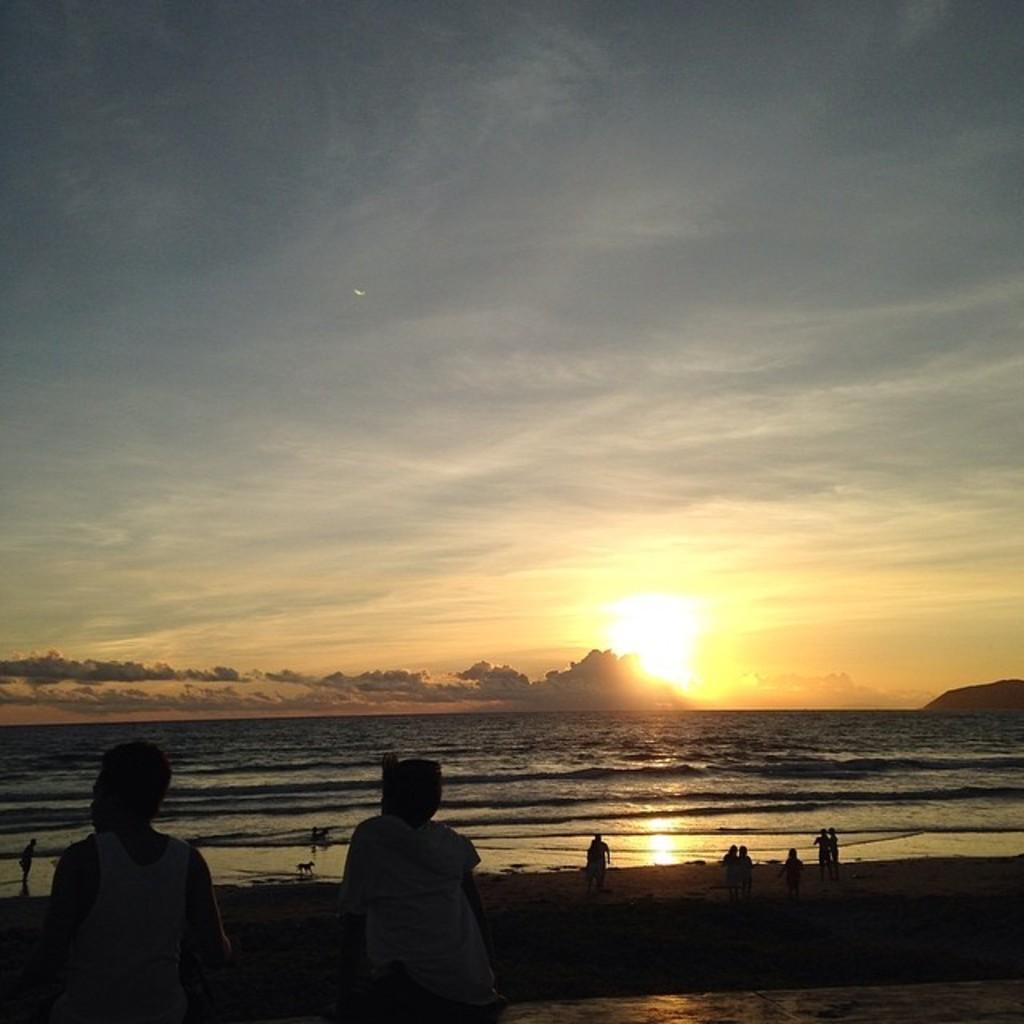In one or two sentences, can you explain what this image depicts? This picture shows few people standing and couple of them are seated and we see a dog and water and few trees and a blue cloudy sky. 